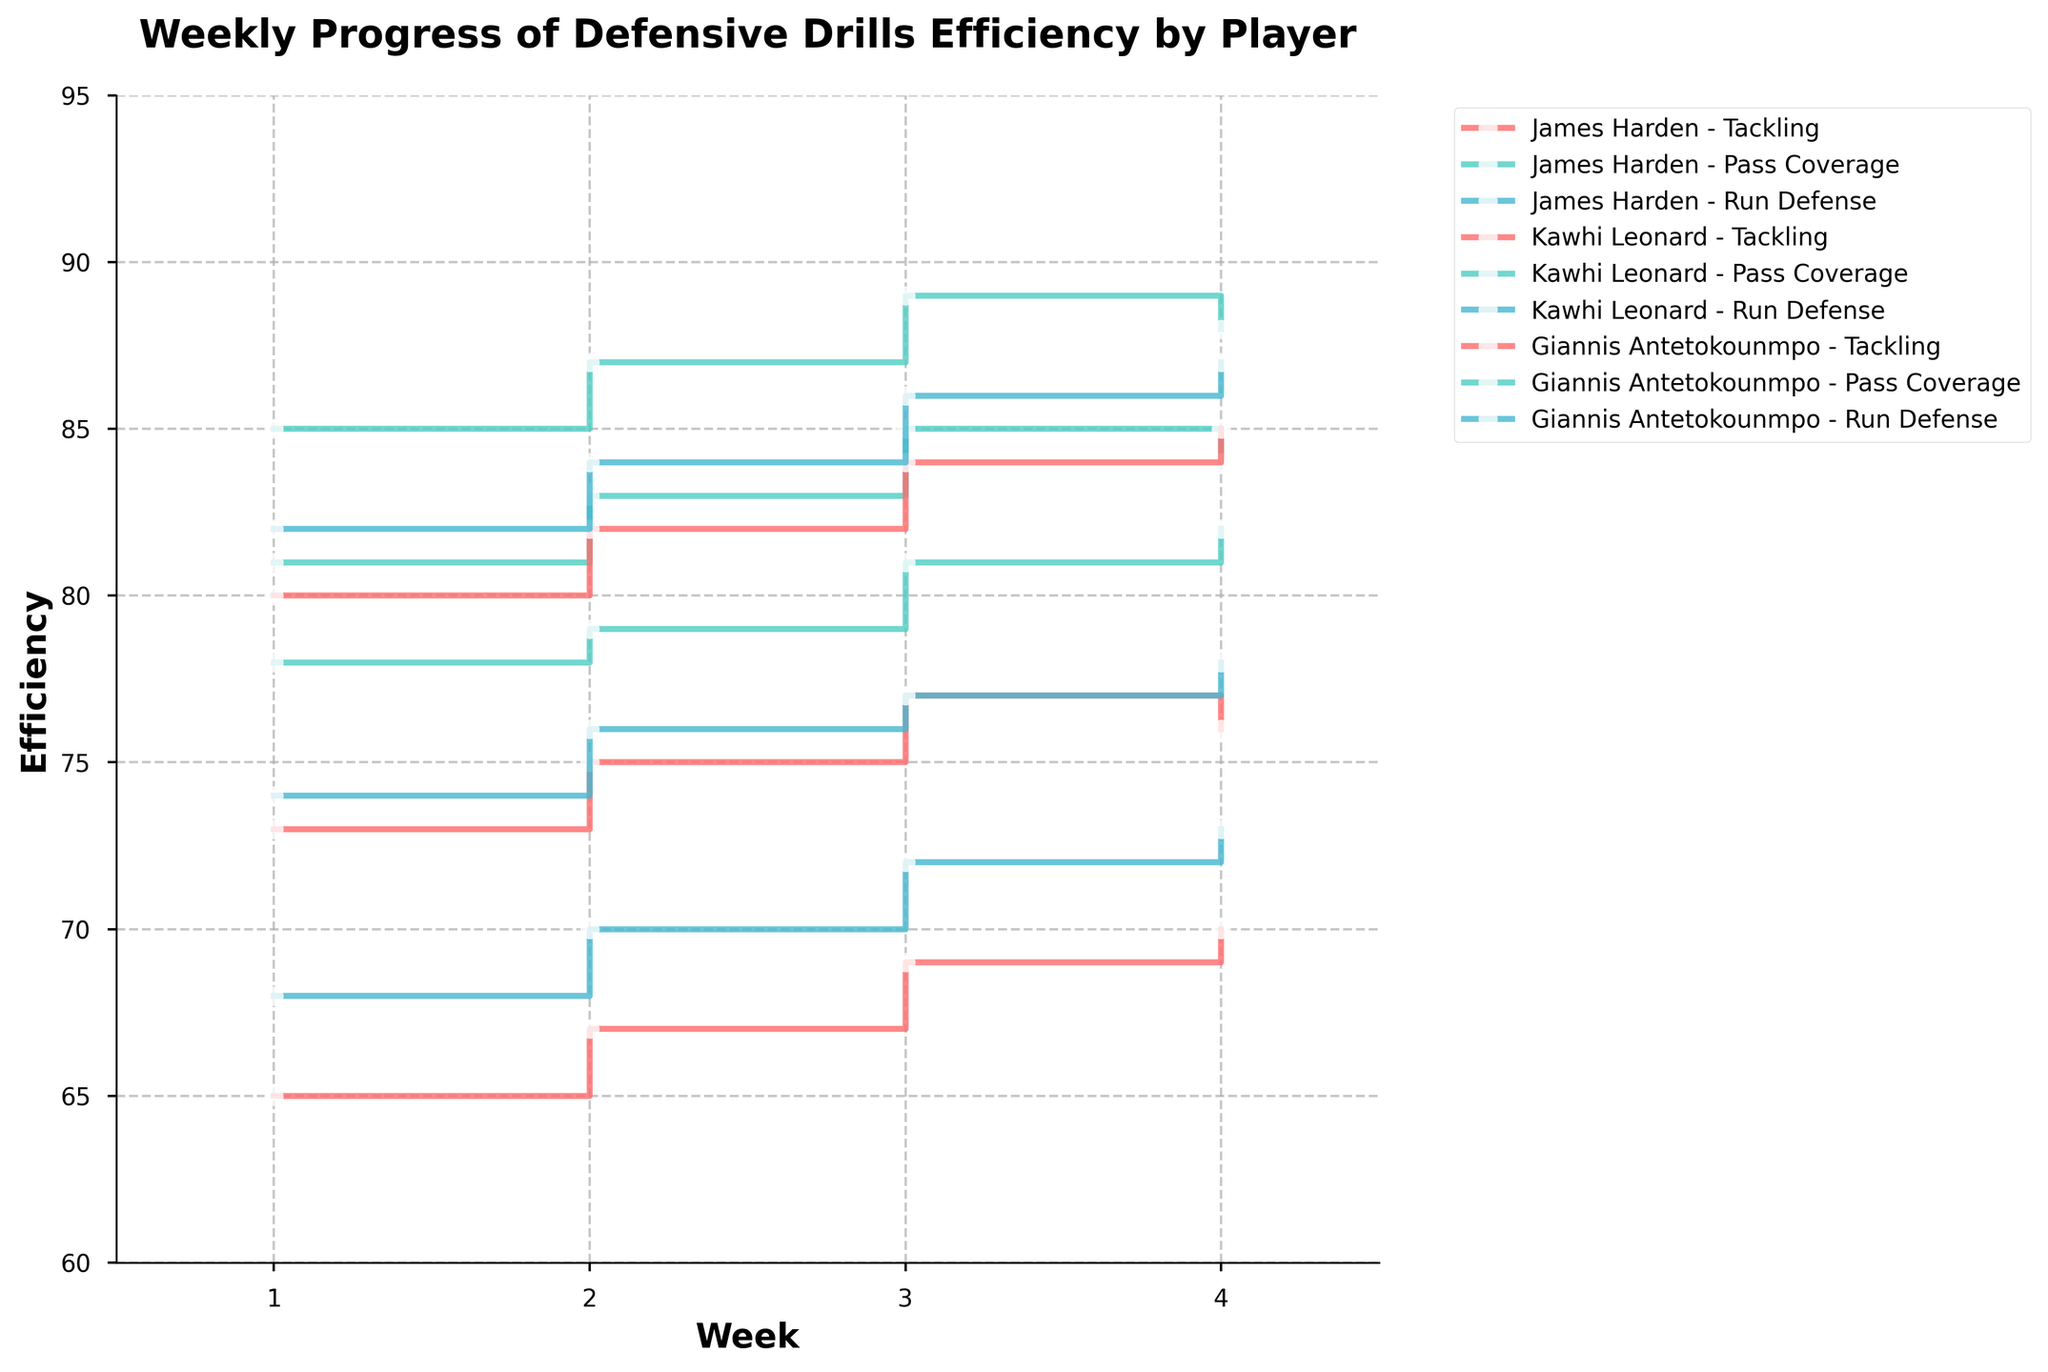Which player showed the highest efficiency in Tackling in Week 1? Look for the player's Tackling efficiency in Week 1 and identify the highest value. In Week 1, James Harden, Kawhi Leonard, and Giannis Antetokounmpo had efficiencies of 73, 65, and 80, respectively.
Answer: Giannis Antetokounmpo What is the title of the figure? Read the title at the top of the plot.
Answer: Weekly Progress of Defensive Drills Efficiency by Player How many weeks are represented on the x-axis? Count the number of distinct weeks shown on the x-axis. The x-axis ranges from 1 to 4, indicating four weeks.
Answer: 4 Which player has the most consistent performance in Tackling over the four weeks? Compare the Tackling efficiency values for each player across all four weeks and identify the one with the smallest variance. Giannis Antetokounmpo's Tackling efficiency values are 80, 82, 84, 85, showing minimal variation.
Answer: Giannis Antetokounmpo Whose Pass Coverage efficiency saw the highest increase from Week 1 to Week 4? Calculate the difference in Pass Coverage efficiency from Week 1 to Week 4 for each player. James Harden's efficiency increased from 81 to 84 (+3), Kawhi Leonard's from 78 to 82 (+4), and Giannis Antetokounmpo's from 85 to 88 (+3). Kawhi Leonard has the highest increase.
Answer: Kawhi Leonard What is the average Run Defense efficiency for Kawhi Leonard over the four weeks? Add the Run Defense efficiencies for Kawhi Leonard for each week and divide by 4. The values are 74, 76, 77, and 78. (74 + 76 + 77 + 78) / 4 = 305 / 4 = 76.25.
Answer: 76.25 How does James Harden's performance in Pass Coverage compare to his performance in Tackling in Week 3? Look at James Harden’s efficiencies in Week 3 for Pass Coverage and Tackling and compare. His Pass Coverage efficiency is 85, while his Tackling efficiency is 77. Pass Coverage is higher.
Answer: Pass Coverage is higher Which drill did Giannis Antetokounmpo perform best in Week 3? Check the efficiency for each drill for Giannis Antetokounmpo in Week 3 and find the highest value. Efficiencies are 84 (Tackling), 89 (Pass Coverage), and 86 (Run Defense). Pass Coverage is the highest.
Answer: Pass Coverage Between which weeks did Kawhi Leonard’s Tackling ability improve the most? Calculate the increase in Tackling efficiency for each pair of consecutive weeks and find the highest. Increases: Week 1 to Week 2 is 67-65=2, Week 2 to Week 3 is 69-67=2, Week 3 to Week 4 is 70-69=1. The largest increase is from Week 1 to Week 3.
Answer: Week 1 to Week 3 